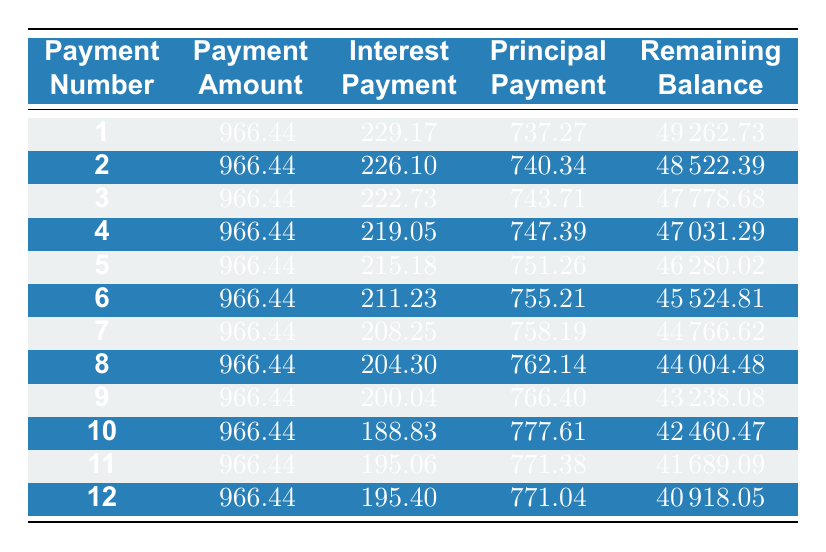What is the payment amount for each month? According to the table, the payment amount is consistently 966.44 for each of the first 12 months.
Answer: 966.44 What is the interest payment for the 5th payment? In the table, the interest payment for the 5th payment is listed as 215.18.
Answer: 215.18 What is the total principal paid after the first three payments? To find the total principal paid, sum the principal payments of the first three rows: 737.27 + 740.34 + 743.71 = 2221.32.
Answer: 2221.32 Is the principal payment for the second month greater than the principal payment for the first month? The principal payment for the second month is 740.34, while for the first month it is 737.27. Since 740.34 is greater than 737.27, the statement is true.
Answer: Yes What is the remaining balance after the 10th payment? According to the table, the remaining balance after the 10th payment is 42460.47.
Answer: 42460.47 What is the average interest payment over the first 6 months? To find the average interest payment, sum the interest payments for the first six months: 229.17 + 226.10 + 222.73 + 219.05 + 215.18 + 211.23 = 1323.56. Then divide by 6: 1323.56 / 6 = 220.59.
Answer: 220.59 Is the interest payment decreasing every month? By examining the interest payment column, it shows a gradual decrease each month, which confirms that it is true.
Answer: Yes What is the total remaining balance after the first two payments? To get the remaining balance after two payments, refer to the remaining balance in the second row, which is 48522.39.
Answer: 48522.39 Which month has the highest principal payment and what is the value? The highest principal payment occurs in the 10th month, which is 777.61.
Answer: 777.61 